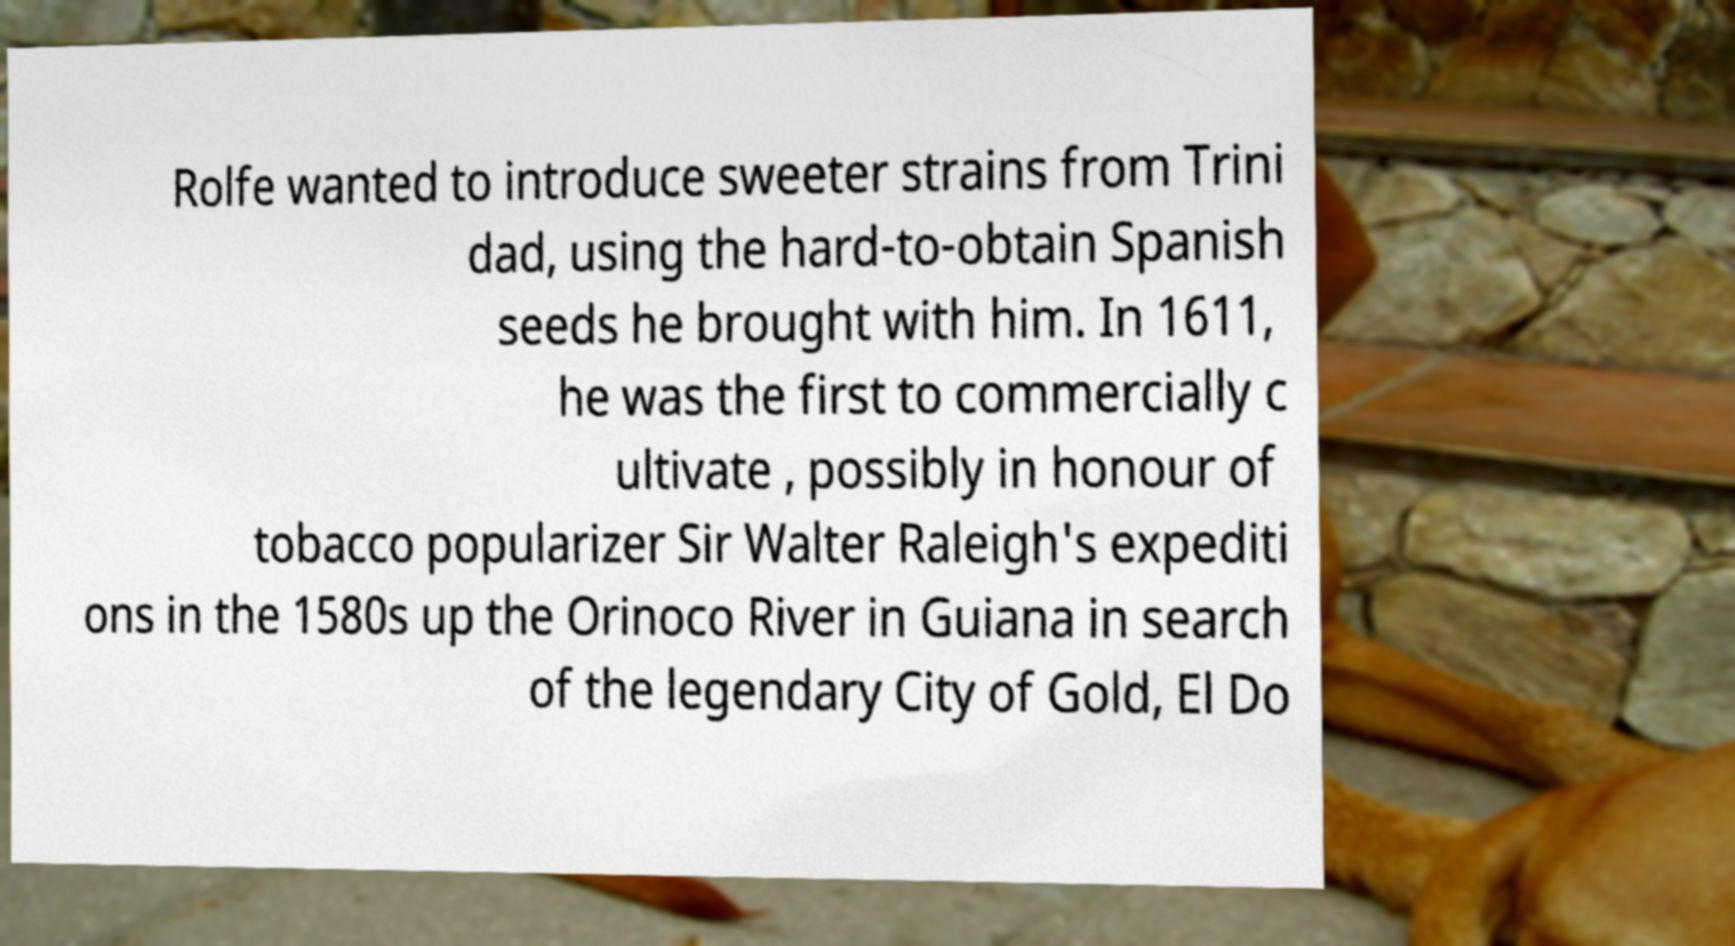I need the written content from this picture converted into text. Can you do that? Rolfe wanted to introduce sweeter strains from Trini dad, using the hard-to-obtain Spanish seeds he brought with him. In 1611, he was the first to commercially c ultivate , possibly in honour of tobacco popularizer Sir Walter Raleigh's expediti ons in the 1580s up the Orinoco River in Guiana in search of the legendary City of Gold, El Do 